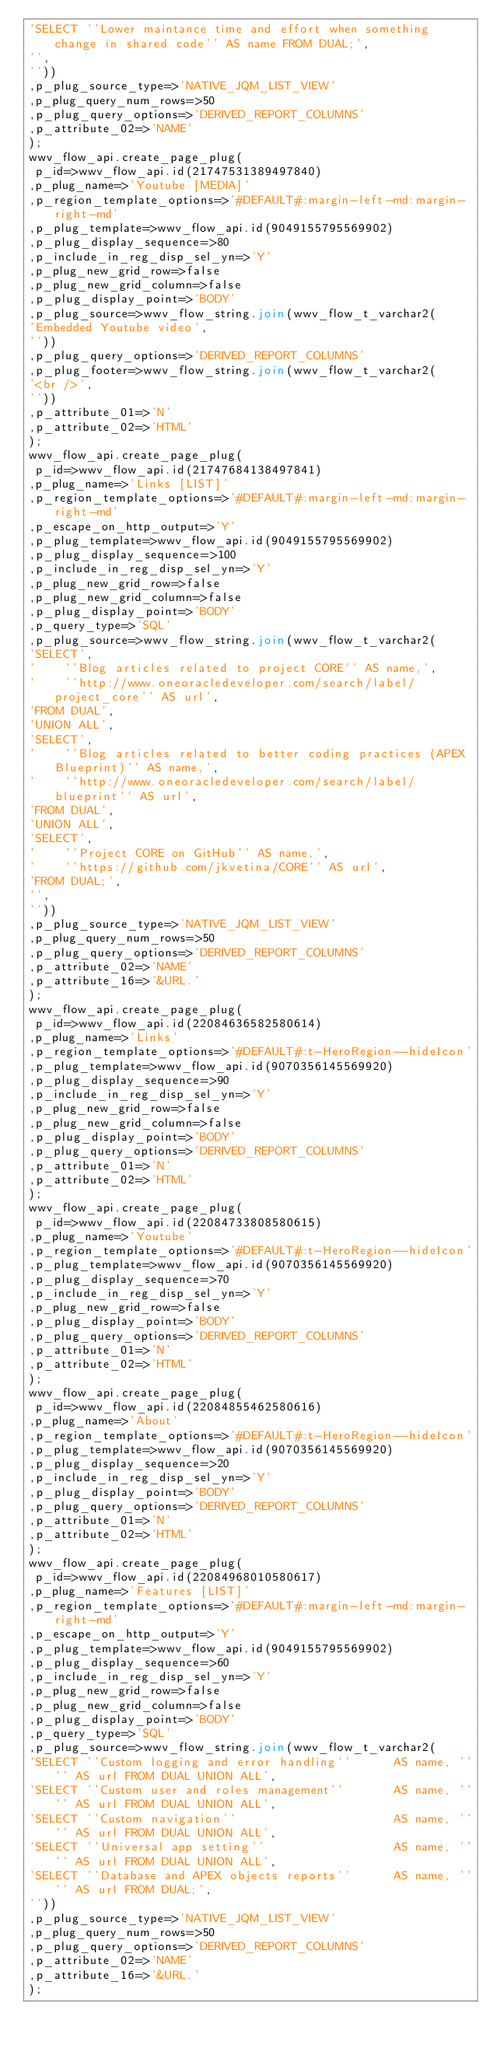Convert code to text. <code><loc_0><loc_0><loc_500><loc_500><_SQL_>'SELECT ''Lower maintance time and effort when something change in shared code'' AS name FROM DUAL;',
'',
''))
,p_plug_source_type=>'NATIVE_JQM_LIST_VIEW'
,p_plug_query_num_rows=>50
,p_plug_query_options=>'DERIVED_REPORT_COLUMNS'
,p_attribute_02=>'NAME'
);
wwv_flow_api.create_page_plug(
 p_id=>wwv_flow_api.id(21747531389497840)
,p_plug_name=>'Youtube [MEDIA]'
,p_region_template_options=>'#DEFAULT#:margin-left-md:margin-right-md'
,p_plug_template=>wwv_flow_api.id(9049155795569902)
,p_plug_display_sequence=>80
,p_include_in_reg_disp_sel_yn=>'Y'
,p_plug_new_grid_row=>false
,p_plug_new_grid_column=>false
,p_plug_display_point=>'BODY'
,p_plug_source=>wwv_flow_string.join(wwv_flow_t_varchar2(
'Embedded Youtube video',
''))
,p_plug_query_options=>'DERIVED_REPORT_COLUMNS'
,p_plug_footer=>wwv_flow_string.join(wwv_flow_t_varchar2(
'<br />',
''))
,p_attribute_01=>'N'
,p_attribute_02=>'HTML'
);
wwv_flow_api.create_page_plug(
 p_id=>wwv_flow_api.id(21747684138497841)
,p_plug_name=>'Links [LIST]'
,p_region_template_options=>'#DEFAULT#:margin-left-md:margin-right-md'
,p_escape_on_http_output=>'Y'
,p_plug_template=>wwv_flow_api.id(9049155795569902)
,p_plug_display_sequence=>100
,p_include_in_reg_disp_sel_yn=>'Y'
,p_plug_new_grid_row=>false
,p_plug_new_grid_column=>false
,p_plug_display_point=>'BODY'
,p_query_type=>'SQL'
,p_plug_source=>wwv_flow_string.join(wwv_flow_t_varchar2(
'SELECT',
'    ''Blog articles related to project CORE'' AS name,',
'    ''http://www.oneoracledeveloper.com/search/label/project_core'' AS url',
'FROM DUAL',
'UNION ALL',
'SELECT',
'    ''Blog articles related to better coding practices (APEX Blueprint)'' AS name,',
'    ''http://www.oneoracledeveloper.com/search/label/blueprint'' AS url',
'FROM DUAL',
'UNION ALL',
'SELECT',
'    ''Project CORE on GitHub'' AS name,',
'    ''https://github.com/jkvetina/CORE'' AS url',
'FROM DUAL;',
'',
''))
,p_plug_source_type=>'NATIVE_JQM_LIST_VIEW'
,p_plug_query_num_rows=>50
,p_plug_query_options=>'DERIVED_REPORT_COLUMNS'
,p_attribute_02=>'NAME'
,p_attribute_16=>'&URL.'
);
wwv_flow_api.create_page_plug(
 p_id=>wwv_flow_api.id(22084636582580614)
,p_plug_name=>'Links'
,p_region_template_options=>'#DEFAULT#:t-HeroRegion--hideIcon'
,p_plug_template=>wwv_flow_api.id(9070356145569920)
,p_plug_display_sequence=>90
,p_include_in_reg_disp_sel_yn=>'Y'
,p_plug_new_grid_row=>false
,p_plug_new_grid_column=>false
,p_plug_display_point=>'BODY'
,p_plug_query_options=>'DERIVED_REPORT_COLUMNS'
,p_attribute_01=>'N'
,p_attribute_02=>'HTML'
);
wwv_flow_api.create_page_plug(
 p_id=>wwv_flow_api.id(22084733808580615)
,p_plug_name=>'Youtube'
,p_region_template_options=>'#DEFAULT#:t-HeroRegion--hideIcon'
,p_plug_template=>wwv_flow_api.id(9070356145569920)
,p_plug_display_sequence=>70
,p_include_in_reg_disp_sel_yn=>'Y'
,p_plug_new_grid_row=>false
,p_plug_display_point=>'BODY'
,p_plug_query_options=>'DERIVED_REPORT_COLUMNS'
,p_attribute_01=>'N'
,p_attribute_02=>'HTML'
);
wwv_flow_api.create_page_plug(
 p_id=>wwv_flow_api.id(22084855462580616)
,p_plug_name=>'About'
,p_region_template_options=>'#DEFAULT#:t-HeroRegion--hideIcon'
,p_plug_template=>wwv_flow_api.id(9070356145569920)
,p_plug_display_sequence=>20
,p_include_in_reg_disp_sel_yn=>'Y'
,p_plug_display_point=>'BODY'
,p_plug_query_options=>'DERIVED_REPORT_COLUMNS'
,p_attribute_01=>'N'
,p_attribute_02=>'HTML'
);
wwv_flow_api.create_page_plug(
 p_id=>wwv_flow_api.id(22084968010580617)
,p_plug_name=>'Features [LIST]'
,p_region_template_options=>'#DEFAULT#:margin-left-md:margin-right-md'
,p_escape_on_http_output=>'Y'
,p_plug_template=>wwv_flow_api.id(9049155795569902)
,p_plug_display_sequence=>60
,p_include_in_reg_disp_sel_yn=>'Y'
,p_plug_new_grid_row=>false
,p_plug_new_grid_column=>false
,p_plug_display_point=>'BODY'
,p_query_type=>'SQL'
,p_plug_source=>wwv_flow_string.join(wwv_flow_t_varchar2(
'SELECT ''Custom logging and error handling''      AS name, '''' AS url FROM DUAL UNION ALL',
'SELECT ''Custom user and roles management''       AS name, '''' AS url FROM DUAL UNION ALL',
'SELECT ''Custom navigation''                      AS name, '''' AS url FROM DUAL UNION ALL',
'SELECT ''Universal app setting''                  AS name, '''' AS url FROM DUAL UNION ALL',
'SELECT ''Database and APEX objects reports''      AS name, '''' AS url FROM DUAL;',
''))
,p_plug_source_type=>'NATIVE_JQM_LIST_VIEW'
,p_plug_query_num_rows=>50
,p_plug_query_options=>'DERIVED_REPORT_COLUMNS'
,p_attribute_02=>'NAME'
,p_attribute_16=>'&URL.'
);</code> 